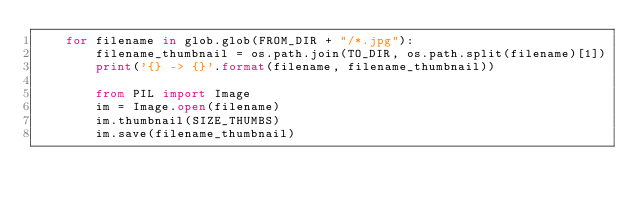<code> <loc_0><loc_0><loc_500><loc_500><_Python_>    for filename in glob.glob(FROM_DIR + "/*.jpg"):
        filename_thumbnail = os.path.join(TO_DIR, os.path.split(filename)[1])
        print('{} -> {}'.format(filename, filename_thumbnail))

        from PIL import Image
        im = Image.open(filename)
        im.thumbnail(SIZE_THUMBS)
        im.save(filename_thumbnail)


</code> 